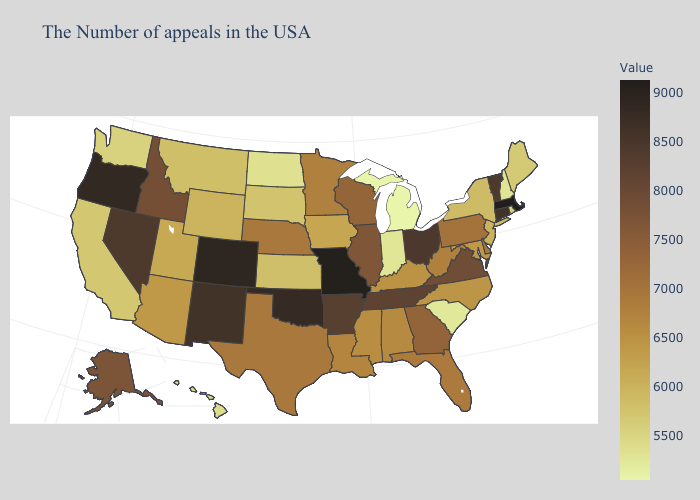Is the legend a continuous bar?
Quick response, please. Yes. Does South Carolina have the lowest value in the South?
Short answer required. Yes. Among the states that border Maryland , which have the lowest value?
Keep it brief. West Virginia. 